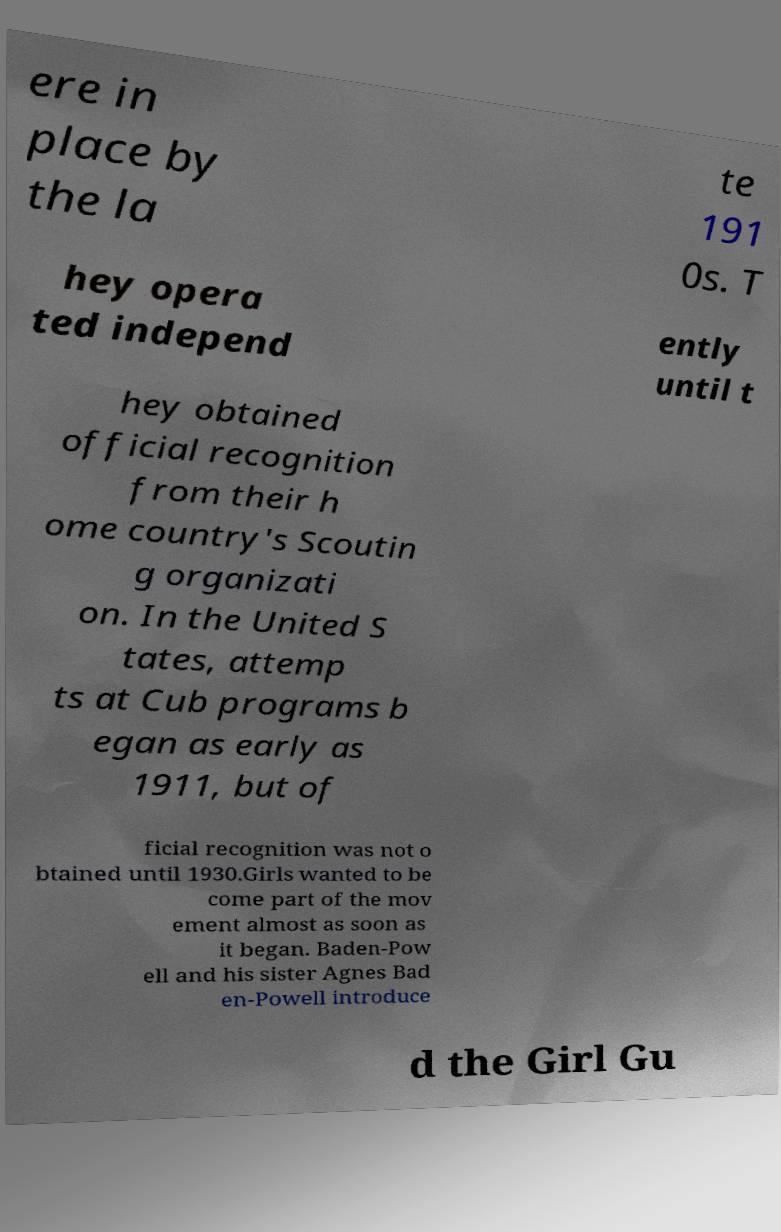Please identify and transcribe the text found in this image. ere in place by the la te 191 0s. T hey opera ted independ ently until t hey obtained official recognition from their h ome country's Scoutin g organizati on. In the United S tates, attemp ts at Cub programs b egan as early as 1911, but of ficial recognition was not o btained until 1930.Girls wanted to be come part of the mov ement almost as soon as it began. Baden-Pow ell and his sister Agnes Bad en-Powell introduce d the Girl Gu 